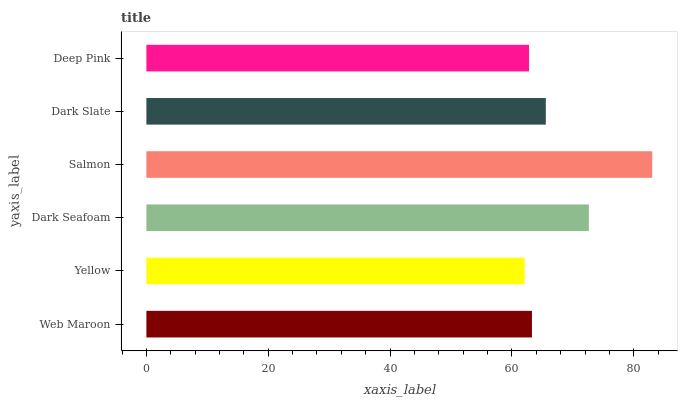Is Yellow the minimum?
Answer yes or no. Yes. Is Salmon the maximum?
Answer yes or no. Yes. Is Dark Seafoam the minimum?
Answer yes or no. No. Is Dark Seafoam the maximum?
Answer yes or no. No. Is Dark Seafoam greater than Yellow?
Answer yes or no. Yes. Is Yellow less than Dark Seafoam?
Answer yes or no. Yes. Is Yellow greater than Dark Seafoam?
Answer yes or no. No. Is Dark Seafoam less than Yellow?
Answer yes or no. No. Is Dark Slate the high median?
Answer yes or no. Yes. Is Web Maroon the low median?
Answer yes or no. Yes. Is Salmon the high median?
Answer yes or no. No. Is Salmon the low median?
Answer yes or no. No. 